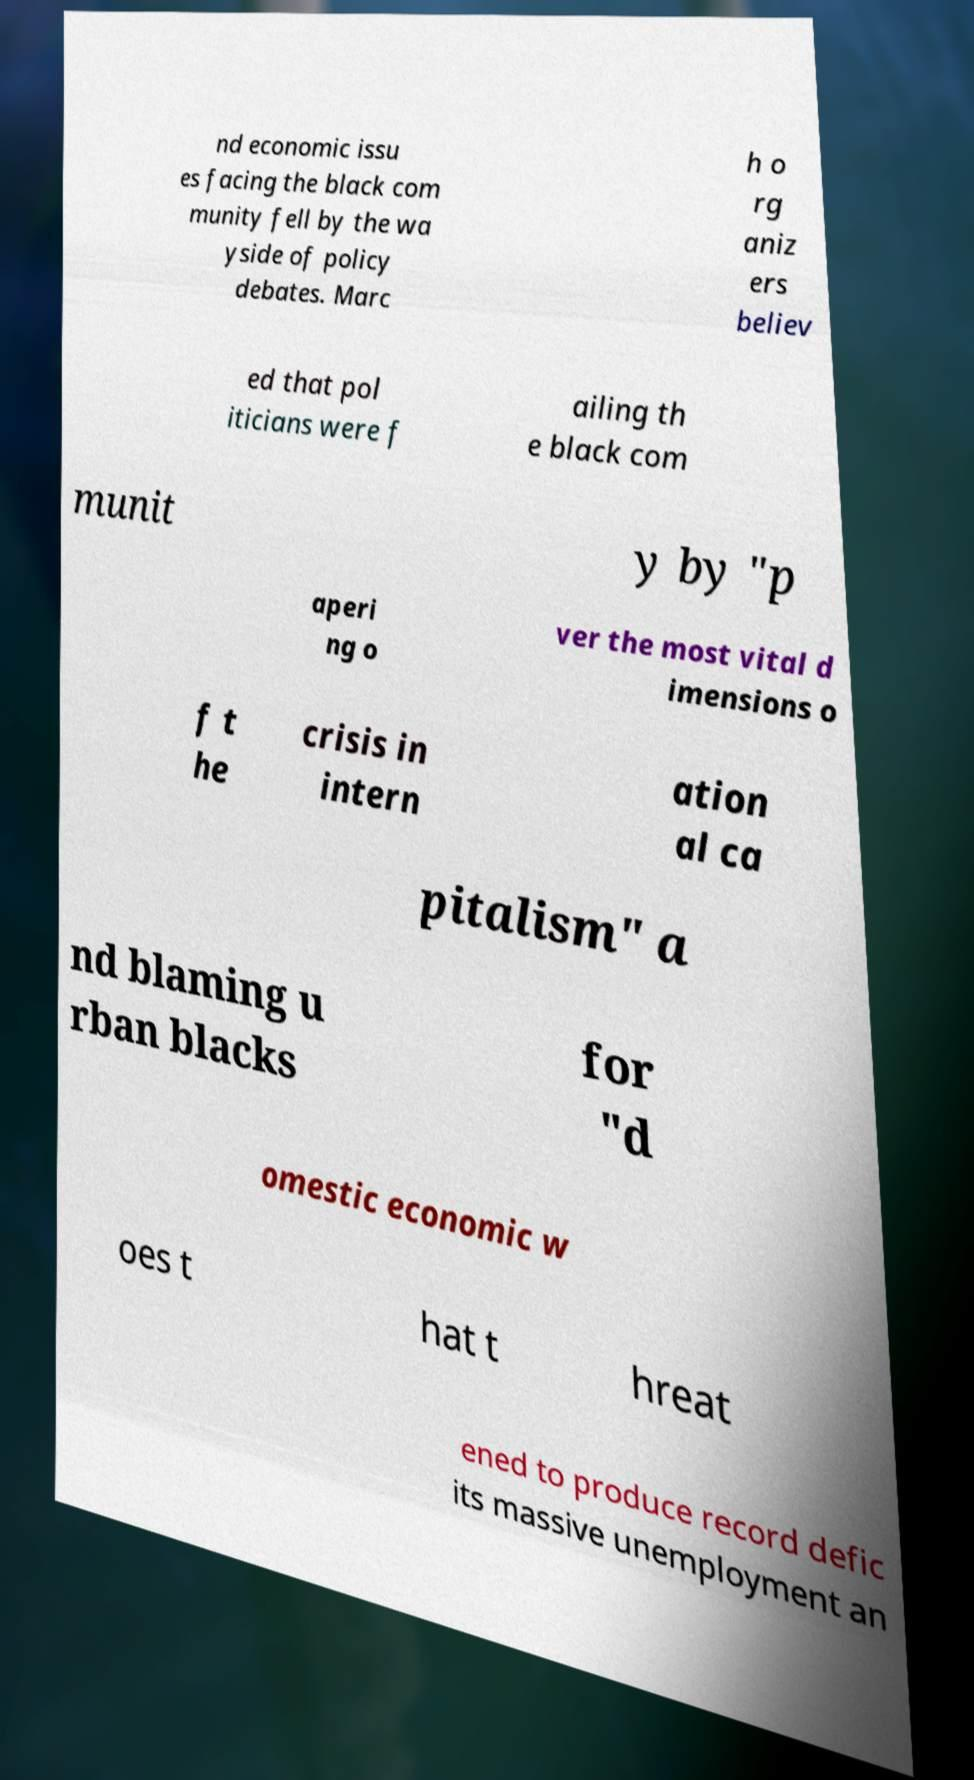Please read and relay the text visible in this image. What does it say? nd economic issu es facing the black com munity fell by the wa yside of policy debates. Marc h o rg aniz ers believ ed that pol iticians were f ailing th e black com munit y by "p aperi ng o ver the most vital d imensions o f t he crisis in intern ation al ca pitalism" a nd blaming u rban blacks for "d omestic economic w oes t hat t hreat ened to produce record defic its massive unemployment an 